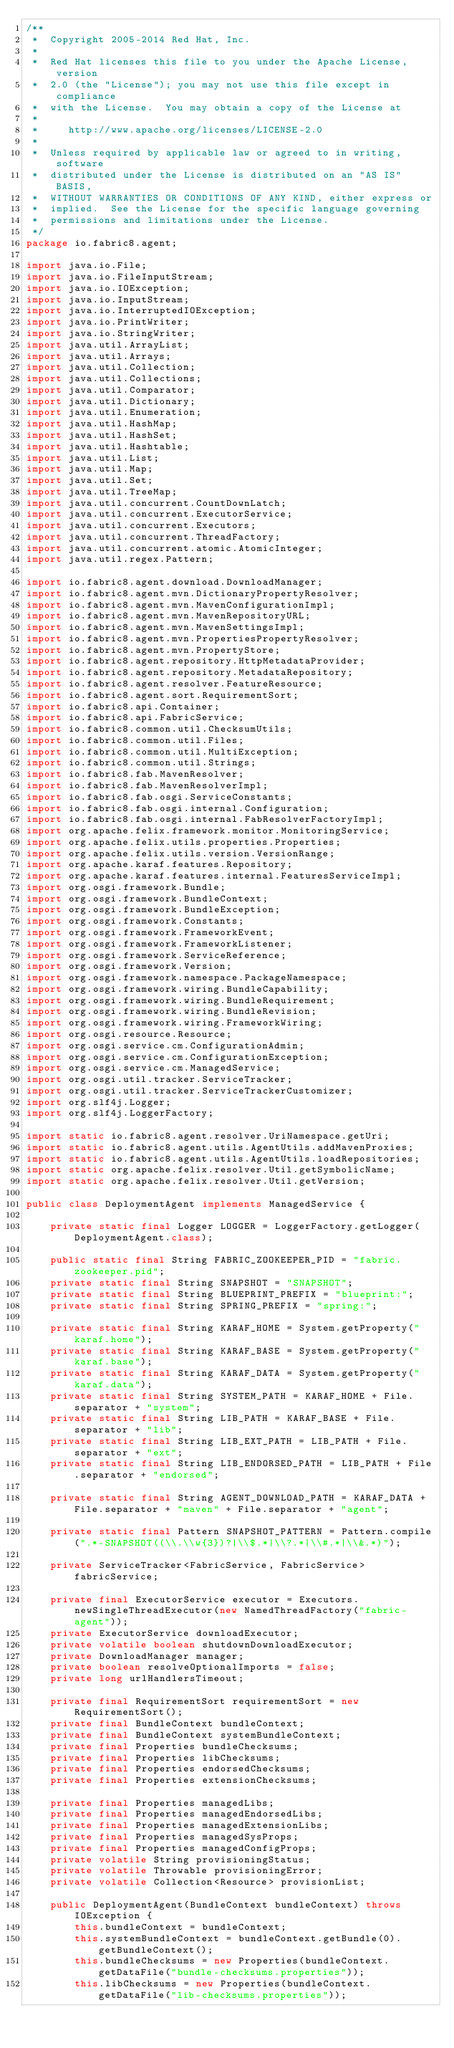<code> <loc_0><loc_0><loc_500><loc_500><_Java_>/**
 *  Copyright 2005-2014 Red Hat, Inc.
 *
 *  Red Hat licenses this file to you under the Apache License, version
 *  2.0 (the "License"); you may not use this file except in compliance
 *  with the License.  You may obtain a copy of the License at
 *
 *     http://www.apache.org/licenses/LICENSE-2.0
 *
 *  Unless required by applicable law or agreed to in writing, software
 *  distributed under the License is distributed on an "AS IS" BASIS,
 *  WITHOUT WARRANTIES OR CONDITIONS OF ANY KIND, either express or
 *  implied.  See the License for the specific language governing
 *  permissions and limitations under the License.
 */
package io.fabric8.agent;

import java.io.File;
import java.io.FileInputStream;
import java.io.IOException;
import java.io.InputStream;
import java.io.InterruptedIOException;
import java.io.PrintWriter;
import java.io.StringWriter;
import java.util.ArrayList;
import java.util.Arrays;
import java.util.Collection;
import java.util.Collections;
import java.util.Comparator;
import java.util.Dictionary;
import java.util.Enumeration;
import java.util.HashMap;
import java.util.HashSet;
import java.util.Hashtable;
import java.util.List;
import java.util.Map;
import java.util.Set;
import java.util.TreeMap;
import java.util.concurrent.CountDownLatch;
import java.util.concurrent.ExecutorService;
import java.util.concurrent.Executors;
import java.util.concurrent.ThreadFactory;
import java.util.concurrent.atomic.AtomicInteger;
import java.util.regex.Pattern;

import io.fabric8.agent.download.DownloadManager;
import io.fabric8.agent.mvn.DictionaryPropertyResolver;
import io.fabric8.agent.mvn.MavenConfigurationImpl;
import io.fabric8.agent.mvn.MavenRepositoryURL;
import io.fabric8.agent.mvn.MavenSettingsImpl;
import io.fabric8.agent.mvn.PropertiesPropertyResolver;
import io.fabric8.agent.mvn.PropertyStore;
import io.fabric8.agent.repository.HttpMetadataProvider;
import io.fabric8.agent.repository.MetadataRepository;
import io.fabric8.agent.resolver.FeatureResource;
import io.fabric8.agent.sort.RequirementSort;
import io.fabric8.api.Container;
import io.fabric8.api.FabricService;
import io.fabric8.common.util.ChecksumUtils;
import io.fabric8.common.util.Files;
import io.fabric8.common.util.MultiException;
import io.fabric8.common.util.Strings;
import io.fabric8.fab.MavenResolver;
import io.fabric8.fab.MavenResolverImpl;
import io.fabric8.fab.osgi.ServiceConstants;
import io.fabric8.fab.osgi.internal.Configuration;
import io.fabric8.fab.osgi.internal.FabResolverFactoryImpl;
import org.apache.felix.framework.monitor.MonitoringService;
import org.apache.felix.utils.properties.Properties;
import org.apache.felix.utils.version.VersionRange;
import org.apache.karaf.features.Repository;
import org.apache.karaf.features.internal.FeaturesServiceImpl;
import org.osgi.framework.Bundle;
import org.osgi.framework.BundleContext;
import org.osgi.framework.BundleException;
import org.osgi.framework.Constants;
import org.osgi.framework.FrameworkEvent;
import org.osgi.framework.FrameworkListener;
import org.osgi.framework.ServiceReference;
import org.osgi.framework.Version;
import org.osgi.framework.namespace.PackageNamespace;
import org.osgi.framework.wiring.BundleCapability;
import org.osgi.framework.wiring.BundleRequirement;
import org.osgi.framework.wiring.BundleRevision;
import org.osgi.framework.wiring.FrameworkWiring;
import org.osgi.resource.Resource;
import org.osgi.service.cm.ConfigurationAdmin;
import org.osgi.service.cm.ConfigurationException;
import org.osgi.service.cm.ManagedService;
import org.osgi.util.tracker.ServiceTracker;
import org.osgi.util.tracker.ServiceTrackerCustomizer;
import org.slf4j.Logger;
import org.slf4j.LoggerFactory;

import static io.fabric8.agent.resolver.UriNamespace.getUri;
import static io.fabric8.agent.utils.AgentUtils.addMavenProxies;
import static io.fabric8.agent.utils.AgentUtils.loadRepositories;
import static org.apache.felix.resolver.Util.getSymbolicName;
import static org.apache.felix.resolver.Util.getVersion;

public class DeploymentAgent implements ManagedService {

    private static final Logger LOGGER = LoggerFactory.getLogger(DeploymentAgent.class);

    public static final String FABRIC_ZOOKEEPER_PID = "fabric.zookeeper.pid";
    private static final String SNAPSHOT = "SNAPSHOT";
    private static final String BLUEPRINT_PREFIX = "blueprint:";
    private static final String SPRING_PREFIX = "spring:";

    private static final String KARAF_HOME = System.getProperty("karaf.home");
    private static final String KARAF_BASE = System.getProperty("karaf.base");
    private static final String KARAF_DATA = System.getProperty("karaf.data");
    private static final String SYSTEM_PATH = KARAF_HOME + File.separator + "system";
    private static final String LIB_PATH = KARAF_BASE + File.separator + "lib";
    private static final String LIB_EXT_PATH = LIB_PATH + File.separator + "ext";
    private static final String LIB_ENDORSED_PATH = LIB_PATH + File.separator + "endorsed";

    private static final String AGENT_DOWNLOAD_PATH = KARAF_DATA + File.separator + "maven" + File.separator + "agent";

    private static final Pattern SNAPSHOT_PATTERN = Pattern.compile(".*-SNAPSHOT((\\.\\w{3})?|\\$.*|\\?.*|\\#.*|\\&.*)");

    private ServiceTracker<FabricService, FabricService> fabricService;

    private final ExecutorService executor = Executors.newSingleThreadExecutor(new NamedThreadFactory("fabric-agent"));
    private ExecutorService downloadExecutor;
    private volatile boolean shutdownDownloadExecutor;
    private DownloadManager manager;
    private boolean resolveOptionalImports = false;
    private long urlHandlersTimeout;

    private final RequirementSort requirementSort = new RequirementSort();
    private final BundleContext bundleContext;
    private final BundleContext systemBundleContext;
    private final Properties bundleChecksums;
    private final Properties libChecksums;
    private final Properties endorsedChecksums;
    private final Properties extensionChecksums;

    private final Properties managedLibs;
    private final Properties managedEndorsedLibs;
    private final Properties managedExtensionLibs;
    private final Properties managedSysProps;
    private final Properties managedConfigProps;
    private volatile String provisioningStatus;
    private volatile Throwable provisioningError;
    private volatile Collection<Resource> provisionList;

    public DeploymentAgent(BundleContext bundleContext) throws IOException {
        this.bundleContext = bundleContext;
        this.systemBundleContext = bundleContext.getBundle(0).getBundleContext();
        this.bundleChecksums = new Properties(bundleContext.getDataFile("bundle-checksums.properties"));
        this.libChecksums = new Properties(bundleContext.getDataFile("lib-checksums.properties"));</code> 